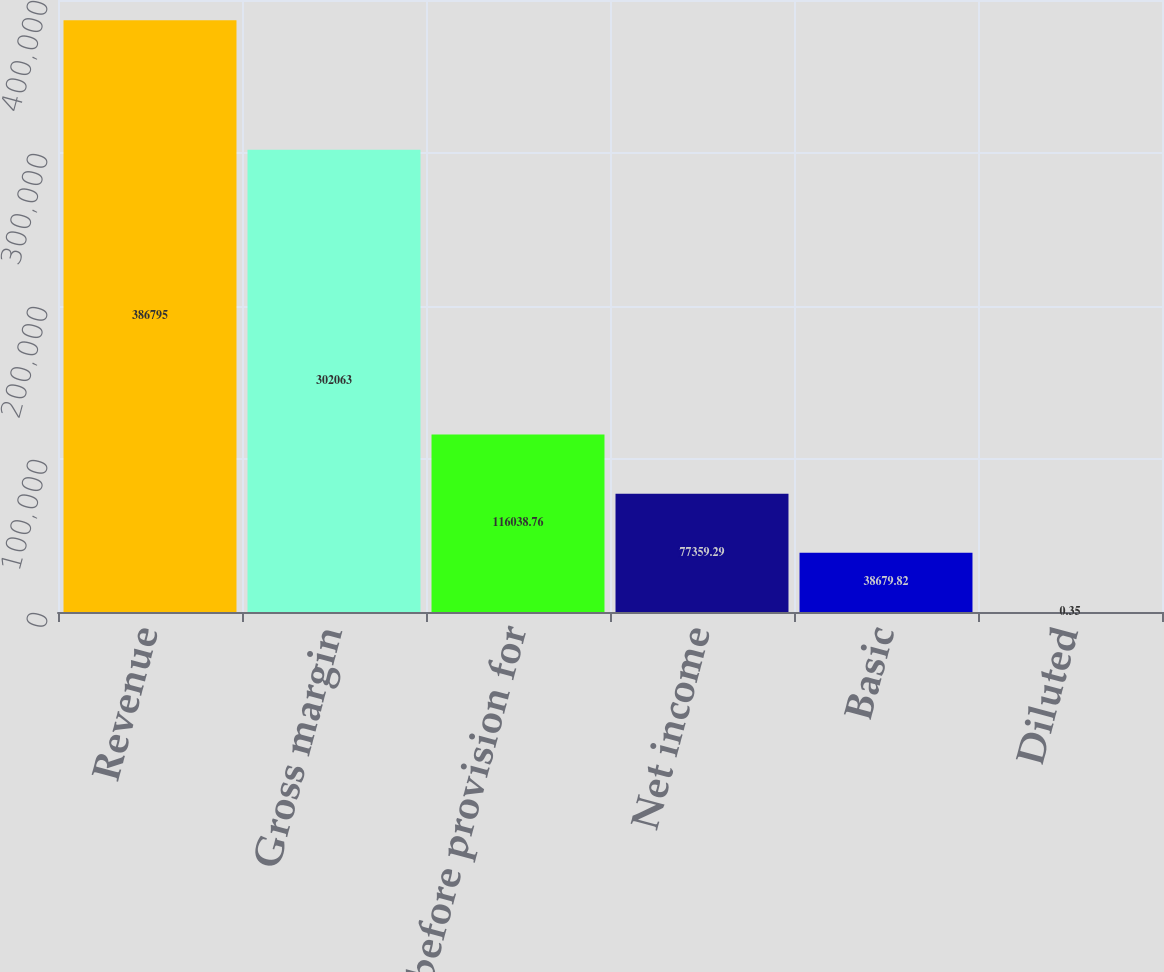<chart> <loc_0><loc_0><loc_500><loc_500><bar_chart><fcel>Revenue<fcel>Gross margin<fcel>Income before provision for<fcel>Net income<fcel>Basic<fcel>Diluted<nl><fcel>386795<fcel>302063<fcel>116039<fcel>77359.3<fcel>38679.8<fcel>0.35<nl></chart> 